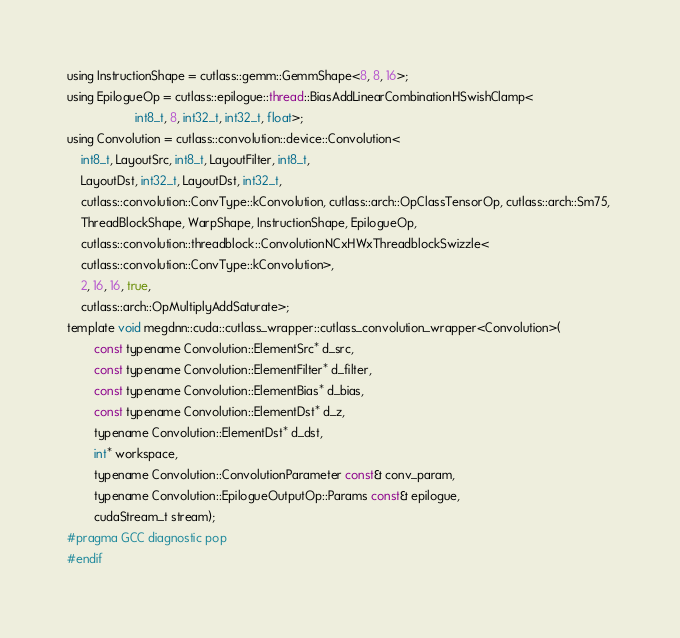<code> <loc_0><loc_0><loc_500><loc_500><_Cuda_>using InstructionShape = cutlass::gemm::GemmShape<8, 8, 16>;
using EpilogueOp = cutlass::epilogue::thread::BiasAddLinearCombinationHSwishClamp<
                    int8_t, 8, int32_t, int32_t, float>;
using Convolution = cutlass::convolution::device::Convolution<
    int8_t, LayoutSrc, int8_t, LayoutFilter, int8_t, 
    LayoutDst, int32_t, LayoutDst, int32_t, 
    cutlass::convolution::ConvType::kConvolution, cutlass::arch::OpClassTensorOp, cutlass::arch::Sm75, 
    ThreadBlockShape, WarpShape, InstructionShape, EpilogueOp, 
    cutlass::convolution::threadblock::ConvolutionNCxHWxThreadblockSwizzle<
    cutlass::convolution::ConvType::kConvolution>, 
    2, 16, 16, true, 
    cutlass::arch::OpMultiplyAddSaturate>;
template void megdnn::cuda::cutlass_wrapper::cutlass_convolution_wrapper<Convolution>(
        const typename Convolution::ElementSrc* d_src, 
        const typename Convolution::ElementFilter* d_filter, 
        const typename Convolution::ElementBias* d_bias, 
        const typename Convolution::ElementDst* d_z, 
        typename Convolution::ElementDst* d_dst, 
        int* workspace, 
        typename Convolution::ConvolutionParameter const& conv_param, 
        typename Convolution::EpilogueOutputOp::Params const& epilogue, 
        cudaStream_t stream);
#pragma GCC diagnostic pop
#endif
</code> 